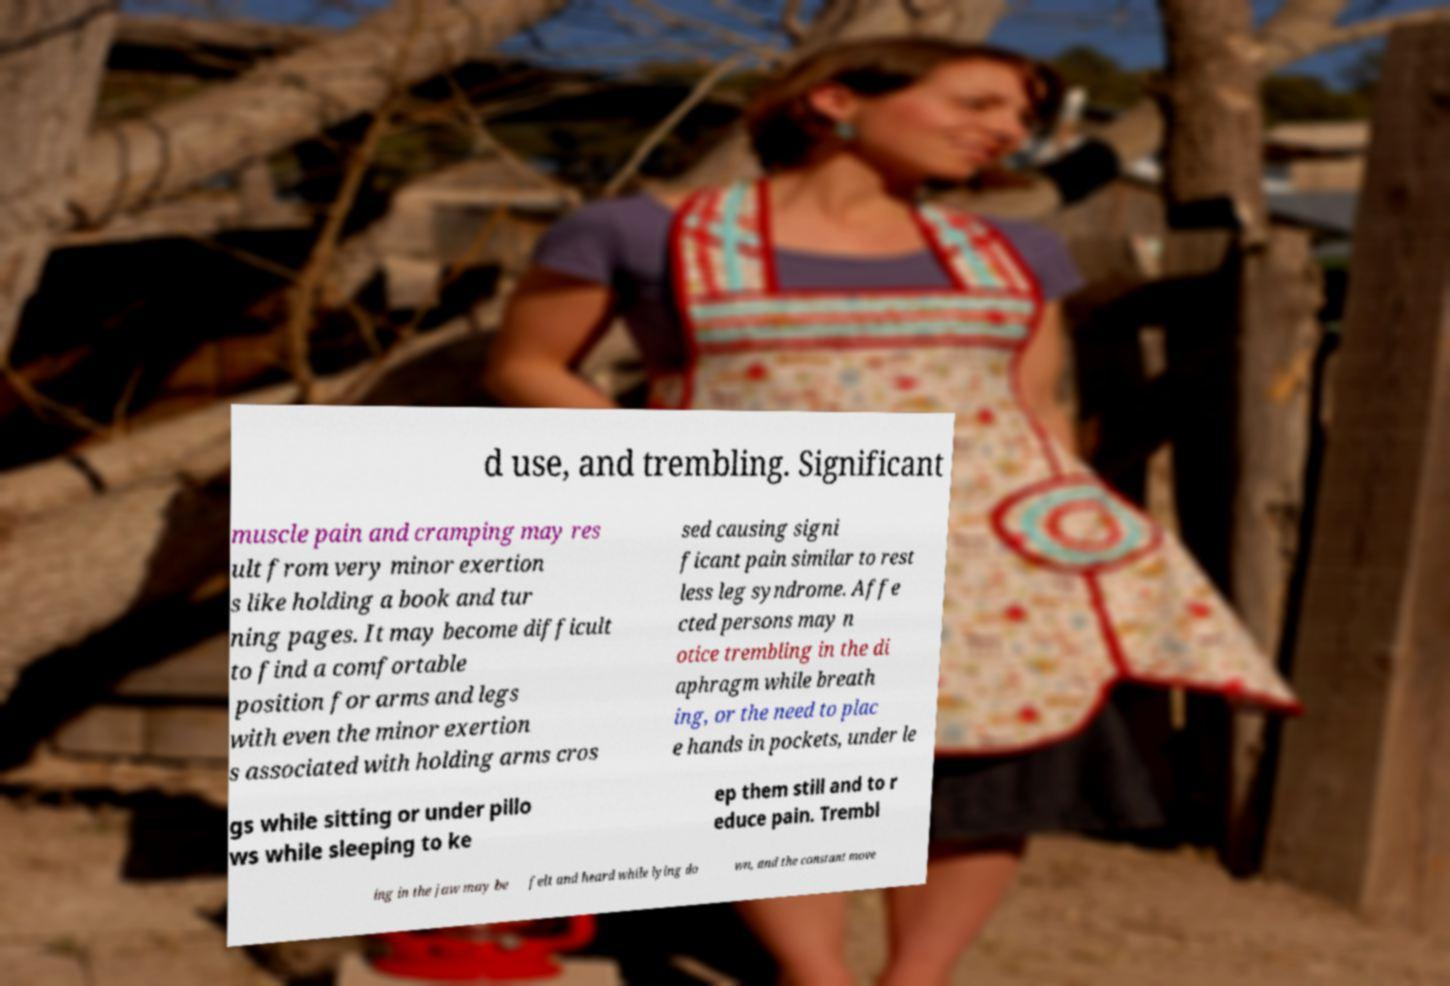I need the written content from this picture converted into text. Can you do that? d use, and trembling. Significant muscle pain and cramping may res ult from very minor exertion s like holding a book and tur ning pages. It may become difficult to find a comfortable position for arms and legs with even the minor exertion s associated with holding arms cros sed causing signi ficant pain similar to rest less leg syndrome. Affe cted persons may n otice trembling in the di aphragm while breath ing, or the need to plac e hands in pockets, under le gs while sitting or under pillo ws while sleeping to ke ep them still and to r educe pain. Trembl ing in the jaw may be felt and heard while lying do wn, and the constant move 